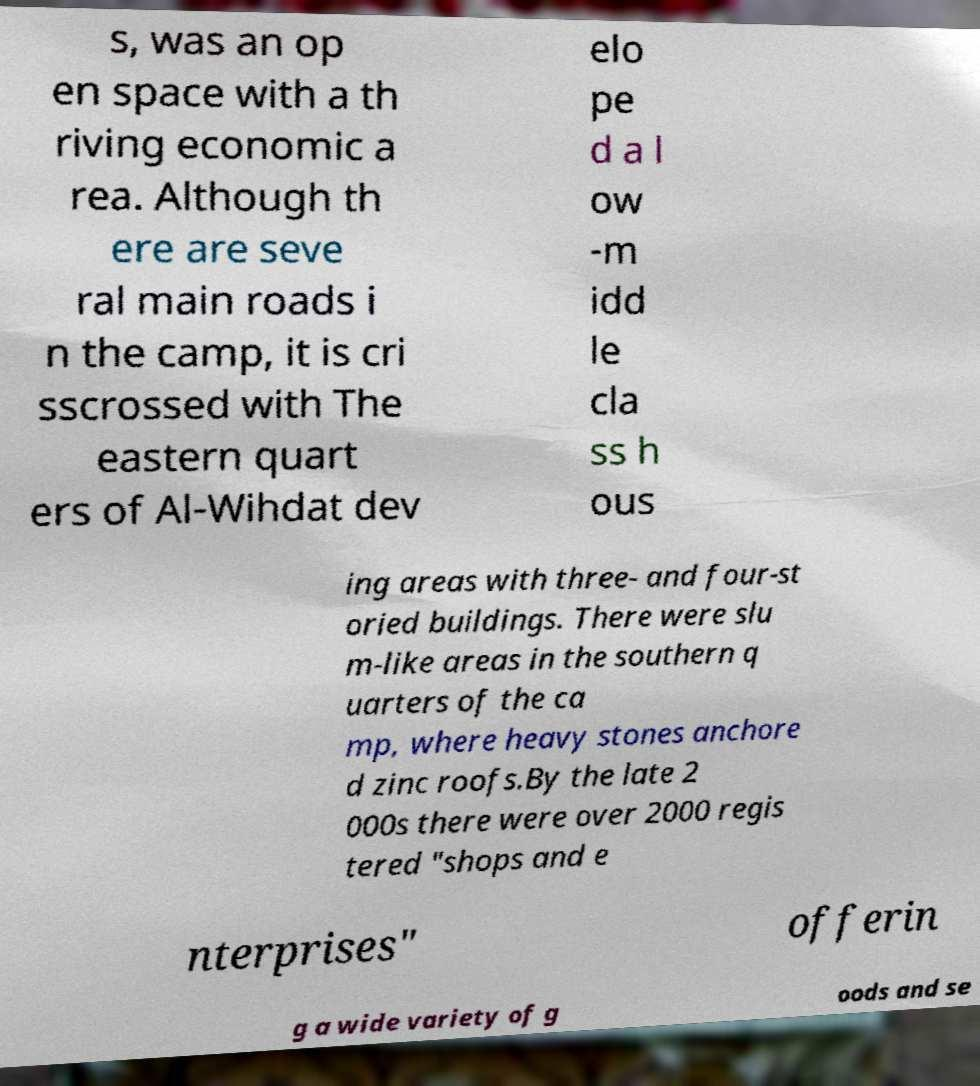For documentation purposes, I need the text within this image transcribed. Could you provide that? s, was an op en space with a th riving economic a rea. Although th ere are seve ral main roads i n the camp, it is cri sscrossed with The eastern quart ers of Al-Wihdat dev elo pe d a l ow -m idd le cla ss h ous ing areas with three- and four-st oried buildings. There were slu m-like areas in the southern q uarters of the ca mp, where heavy stones anchore d zinc roofs.By the late 2 000s there were over 2000 regis tered "shops and e nterprises" offerin g a wide variety of g oods and se 